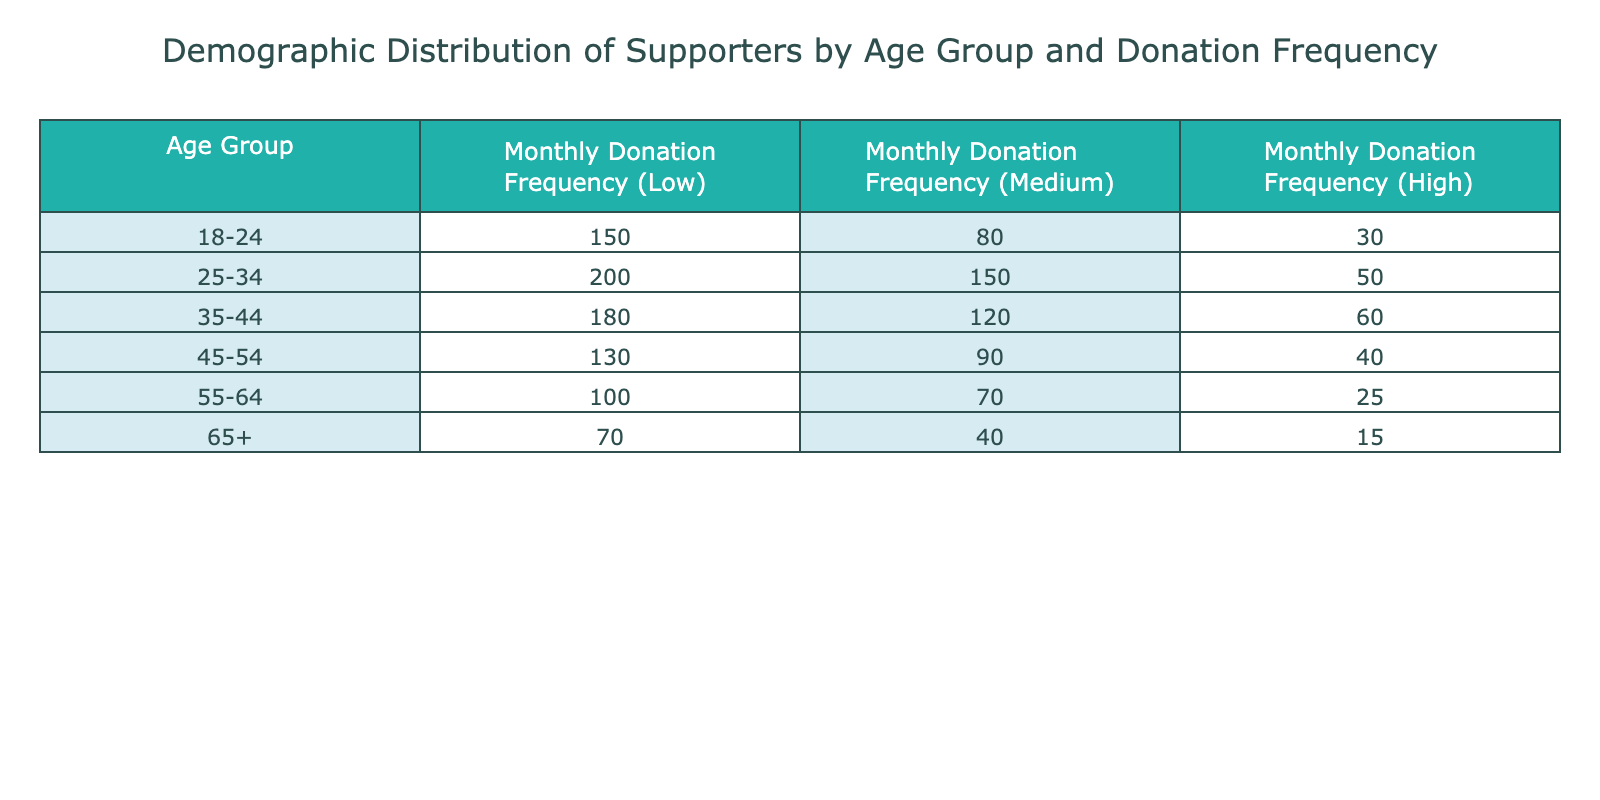What is the total number of supporters in the age group 25-34? To find the total number of supporters in the age group 25-34, we need to sum the monthly donation frequencies. The values for this age group are 200 for low, 150 for medium, and 50 for high donations. Thus, the total is 200 + 150 + 50 = 400.
Answer: 400 How many supporters aged 55-64 contribute at a high donation frequency? From the table, the value for the age group 55-64 under high monthly donation frequency is 25. This is a direct lookup of the corresponding value in the table.
Answer: 25 What is the average number of supporters across all age groups for medium donation frequency? First, we calculate the total number of supporters contributing at a medium frequency: 80 + 150 + 120 + 90 + 70 + 40 = 550. There are 6 age groups, so to find the average, we divide the total by the number of age groups: 550/6 ≈ 91.67.
Answer: 91.67 Is there a higher number of supporters aged 35-44 in the low donation frequency compared to those aged 45-54 in the medium donation frequency? For the age group 35-44, the low donation frequency is 180. For the age group 45-54, the medium donation frequency is 90. Since 180 > 90, the statement is true.
Answer: Yes Which age group has the lowest total number of supporters when combining all donation frequencies? We sum supporters for each age group: 18-24 (150 + 80 + 30 = 260), 25-34 (200 + 150 + 50 = 400), 35-44 (180 + 120 + 60 = 360), 45-54 (130 + 90 + 40 = 260), 55-64 (100 + 70 + 25 = 195), and 65+ (70 + 40 + 15 = 125). The lowest sum is for the age group 65+, which totals 125 supporters.
Answer: 65+ What is the difference in the total number of monthly donations between those aged 25-34 and those aged 55-64? First, calculate the total for both age groups: For 25-34, 200 + 150 + 50 = 400; for 55-64, 100 + 70 + 25 = 195. Now, find the difference: 400 - 195 = 205.
Answer: 205 